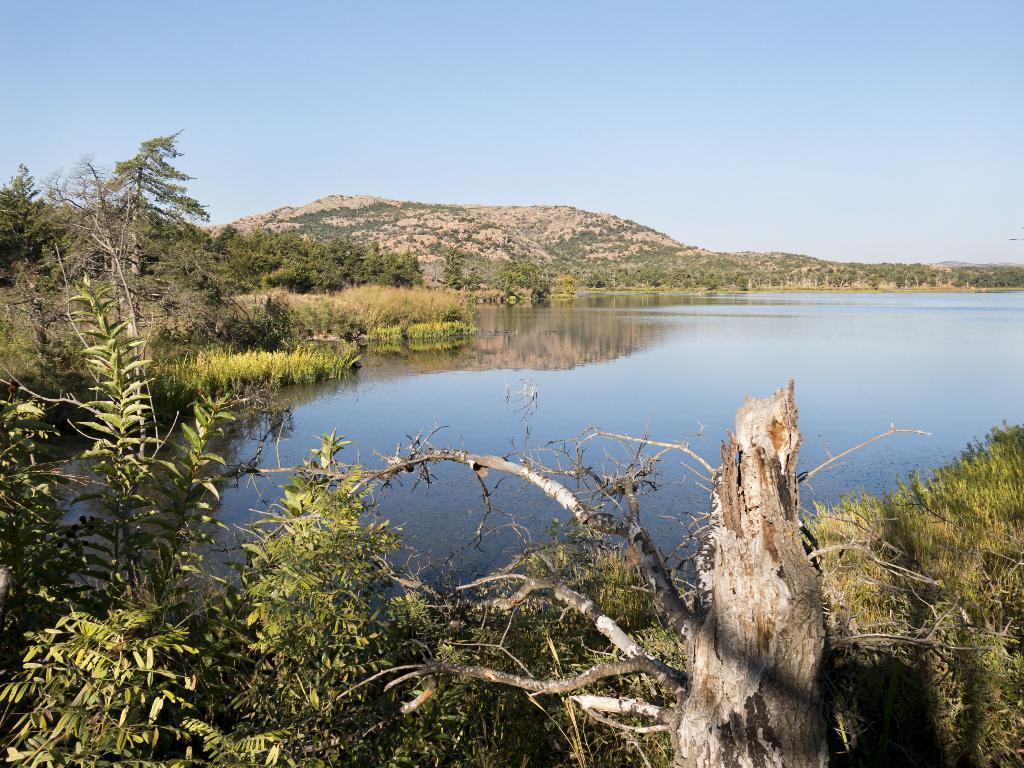Can you describe this image briefly? In this image we can see water. Also there is grass, plants and trees. In the back there is sky and hill. 